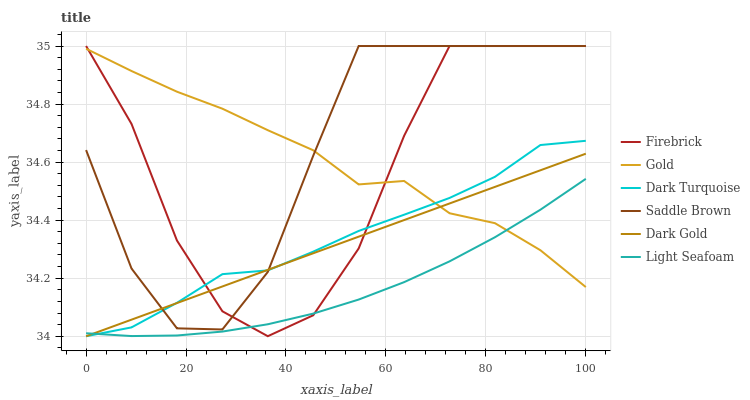Does Light Seafoam have the minimum area under the curve?
Answer yes or no. Yes. Does Saddle Brown have the maximum area under the curve?
Answer yes or no. Yes. Does Dark Gold have the minimum area under the curve?
Answer yes or no. No. Does Dark Gold have the maximum area under the curve?
Answer yes or no. No. Is Dark Gold the smoothest?
Answer yes or no. Yes. Is Firebrick the roughest?
Answer yes or no. Yes. Is Dark Turquoise the smoothest?
Answer yes or no. No. Is Dark Turquoise the roughest?
Answer yes or no. No. Does Dark Gold have the lowest value?
Answer yes or no. Yes. Does Firebrick have the lowest value?
Answer yes or no. No. Does Saddle Brown have the highest value?
Answer yes or no. Yes. Does Dark Gold have the highest value?
Answer yes or no. No. Is Light Seafoam less than Saddle Brown?
Answer yes or no. Yes. Is Saddle Brown greater than Light Seafoam?
Answer yes or no. Yes. Does Dark Turquoise intersect Firebrick?
Answer yes or no. Yes. Is Dark Turquoise less than Firebrick?
Answer yes or no. No. Is Dark Turquoise greater than Firebrick?
Answer yes or no. No. Does Light Seafoam intersect Saddle Brown?
Answer yes or no. No. 